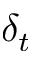<formula> <loc_0><loc_0><loc_500><loc_500>\delta _ { t }</formula> 